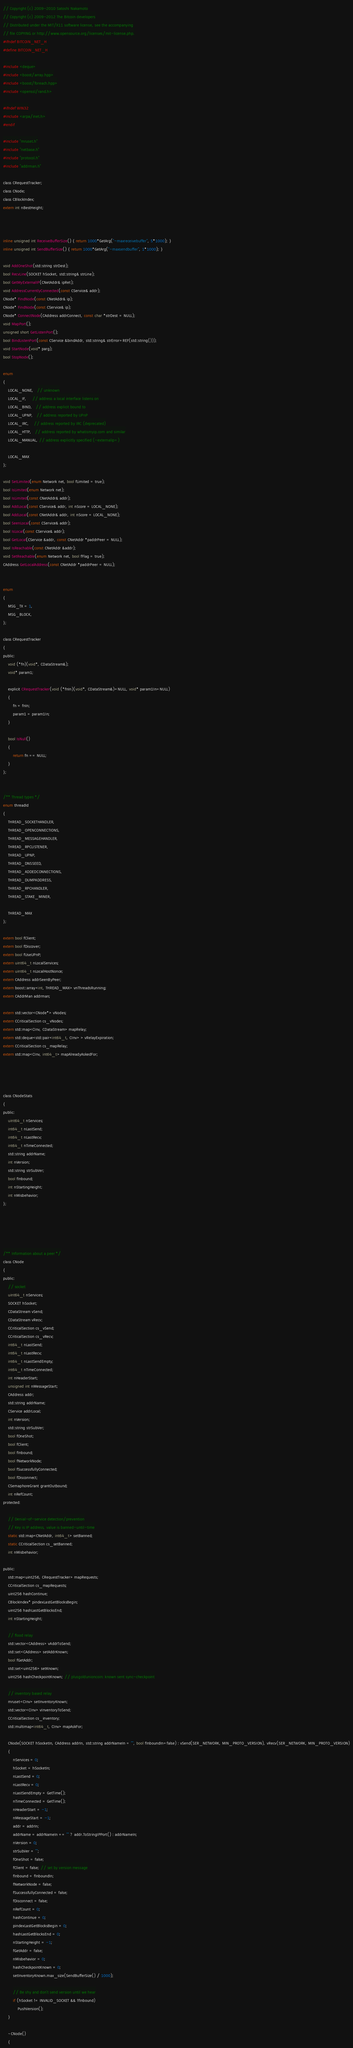<code> <loc_0><loc_0><loc_500><loc_500><_C_>// Copyright (c) 2009-2010 Satoshi Nakamoto
// Copyright (c) 2009-2012 The Bitcoin developers
// Distributed under the MIT/X11 software license, see the accompanying
// file COPYING or http://www.opensource.org/licenses/mit-license.php.
#ifndef BITCOIN_NET_H
#define BITCOIN_NET_H

#include <deque>
#include <boost/array.hpp>
#include <boost/foreach.hpp>
#include <openssl/rand.h>

#ifndef WIN32
#include <arpa/inet.h>
#endif

#include "mruset.h"
#include "netbase.h"
#include "protocol.h"
#include "addrman.h"

class CRequestTracker;
class CNode;
class CBlockIndex;
extern int nBestHeight;



inline unsigned int ReceiveBufferSize() { return 1000*GetArg("-maxreceivebuffer", 5*1000); }
inline unsigned int SendBufferSize() { return 1000*GetArg("-maxsendbuffer", 1*1000); }

void AddOneShot(std::string strDest);
bool RecvLine(SOCKET hSocket, std::string& strLine);
bool GetMyExternalIP(CNetAddr& ipRet);
void AddressCurrentlyConnected(const CService& addr);
CNode* FindNode(const CNetAddr& ip);
CNode* FindNode(const CService& ip);
CNode* ConnectNode(CAddress addrConnect, const char *strDest = NULL);
void MapPort();
unsigned short GetListenPort();
bool BindListenPort(const CService &bindAddr, std::string& strError=REF(std::string()));
void StartNode(void* parg);
bool StopNode();

enum
{
    LOCAL_NONE,   // unknown
    LOCAL_IF,     // address a local interface listens on
    LOCAL_BIND,   // address explicit bound to
    LOCAL_UPNP,   // address reported by UPnP
    LOCAL_IRC,    // address reported by IRC (deprecated)
    LOCAL_HTTP,   // address reported by whatismyip.com and similar
    LOCAL_MANUAL, // address explicitly specified (-externalip=)

    LOCAL_MAX
};

void SetLimited(enum Network net, bool fLimited = true);
bool IsLimited(enum Network net);
bool IsLimited(const CNetAddr& addr);
bool AddLocal(const CService& addr, int nScore = LOCAL_NONE);
bool AddLocal(const CNetAddr& addr, int nScore = LOCAL_NONE);
bool SeenLocal(const CService& addr);
bool IsLocal(const CService& addr);
bool GetLocal(CService &addr, const CNetAddr *paddrPeer = NULL);
bool IsReachable(const CNetAddr &addr);
void SetReachable(enum Network net, bool fFlag = true);
CAddress GetLocalAddress(const CNetAddr *paddrPeer = NULL);


enum
{
    MSG_TX = 1,
    MSG_BLOCK,
};

class CRequestTracker
{
public:
    void (*fn)(void*, CDataStream&);
    void* param1;

    explicit CRequestTracker(void (*fnIn)(void*, CDataStream&)=NULL, void* param1In=NULL)
    {
        fn = fnIn;
        param1 = param1In;
    }

    bool IsNull()
    {
        return fn == NULL;
    }
};


/** Thread types */
enum threadId
{
    THREAD_SOCKETHANDLER,
    THREAD_OPENCONNECTIONS,
    THREAD_MESSAGEHANDLER,
    THREAD_RPCLISTENER,
    THREAD_UPNP,
    THREAD_DNSSEED,
    THREAD_ADDEDCONNECTIONS,
    THREAD_DUMPADDRESS,
    THREAD_RPCHANDLER,
    THREAD_STAKE_MINER,

    THREAD_MAX
};

extern bool fClient;
extern bool fDiscover;
extern bool fUseUPnP;
extern uint64_t nLocalServices;
extern uint64_t nLocalHostNonce;
extern CAddress addrSeenByPeer;
extern boost::array<int, THREAD_MAX> vnThreadsRunning;
extern CAddrMan addrman;

extern std::vector<CNode*> vNodes;
extern CCriticalSection cs_vNodes;
extern std::map<CInv, CDataStream> mapRelay;
extern std::deque<std::pair<int64_t, CInv> > vRelayExpiration;
extern CCriticalSection cs_mapRelay;
extern std::map<CInv, int64_t> mapAlreadyAskedFor;




class CNodeStats
{
public:
    uint64_t nServices;
    int64_t nLastSend;
    int64_t nLastRecv;
    int64_t nTimeConnected;
    std::string addrName;
    int nVersion;
    std::string strSubVer;
    bool fInbound;
    int nStartingHeight;
    int nMisbehavior;
};





/** Information about a peer */
class CNode
{
public:
    // socket
    uint64_t nServices;
    SOCKET hSocket;
    CDataStream vSend;
    CDataStream vRecv;
    CCriticalSection cs_vSend;
    CCriticalSection cs_vRecv;
    int64_t nLastSend;
    int64_t nLastRecv;
    int64_t nLastSendEmpty;
    int64_t nTimeConnected;
    int nHeaderStart;
    unsigned int nMessageStart;
    CAddress addr;
    std::string addrName;
    CService addrLocal;
    int nVersion;
    std::string strSubVer;
    bool fOneShot;
    bool fClient;
    bool fInbound;
    bool fNetworkNode;
    bool fSuccessfullyConnected;
    bool fDisconnect;
    CSemaphoreGrant grantOutbound;
    int nRefCount;
protected:

    // Denial-of-service detection/prevention
    // Key is IP address, value is banned-until-time
    static std::map<CNetAddr, int64_t> setBanned;
    static CCriticalSection cs_setBanned;
    int nMisbehavior;

public:
    std::map<uint256, CRequestTracker> mapRequests;
    CCriticalSection cs_mapRequests;
    uint256 hashContinue;
    CBlockIndex* pindexLastGetBlocksBegin;
    uint256 hashLastGetBlocksEnd;
    int nStartingHeight;

    // flood relay
    std::vector<CAddress> vAddrToSend;
    std::set<CAddress> setAddrKnown;
    bool fGetAddr;
    std::set<uint256> setKnown;
    uint256 hashCheckpointKnown; // plusgoldunioncoin: known sent sync-checkpoint

    // inventory based relay
    mruset<CInv> setInventoryKnown;
    std::vector<CInv> vInventoryToSend;
    CCriticalSection cs_inventory;
    std::multimap<int64_t, CInv> mapAskFor;

    CNode(SOCKET hSocketIn, CAddress addrIn, std::string addrNameIn = "", bool fInboundIn=false) : vSend(SER_NETWORK, MIN_PROTO_VERSION), vRecv(SER_NETWORK, MIN_PROTO_VERSION)
    {
        nServices = 0;
        hSocket = hSocketIn;
        nLastSend = 0;
        nLastRecv = 0;
        nLastSendEmpty = GetTime();
        nTimeConnected = GetTime();
        nHeaderStart = -1;
        nMessageStart = -1;
        addr = addrIn;
        addrName = addrNameIn == "" ? addr.ToStringIPPort() : addrNameIn;
        nVersion = 0;
        strSubVer = "";
        fOneShot = false;
        fClient = false; // set by version message
        fInbound = fInboundIn;
        fNetworkNode = false;
        fSuccessfullyConnected = false;
        fDisconnect = false;
        nRefCount = 0;
        hashContinue = 0;
        pindexLastGetBlocksBegin = 0;
        hashLastGetBlocksEnd = 0;
        nStartingHeight = -1;
        fGetAddr = false;
        nMisbehavior = 0;
        hashCheckpointKnown = 0;
        setInventoryKnown.max_size(SendBufferSize() / 1000);

        // Be shy and don't send version until we hear
        if (hSocket != INVALID_SOCKET && !fInbound)
            PushVersion();
    }

    ~CNode()
    {</code> 